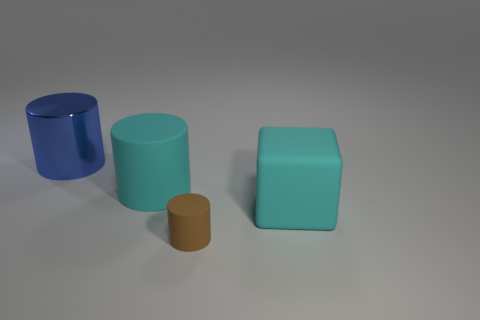Add 3 large purple rubber spheres. How many objects exist? 7 Subtract all big blue cylinders. How many cylinders are left? 2 Subtract all cubes. How many objects are left? 3 Subtract all brown cylinders. How many cylinders are left? 2 Subtract all cylinders. Subtract all purple rubber balls. How many objects are left? 1 Add 2 blue shiny things. How many blue shiny things are left? 3 Add 3 cyan rubber blocks. How many cyan rubber blocks exist? 4 Subtract 0 red spheres. How many objects are left? 4 Subtract all yellow cylinders. Subtract all blue cubes. How many cylinders are left? 3 